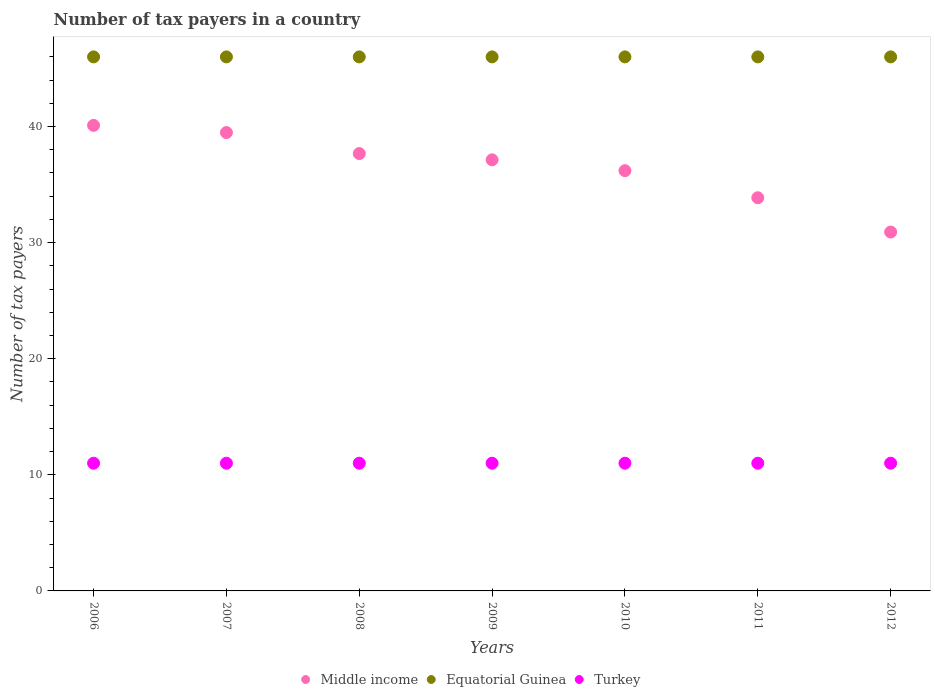How many different coloured dotlines are there?
Your answer should be compact. 3. What is the number of tax payers in in Turkey in 2011?
Your response must be concise. 11. Across all years, what is the maximum number of tax payers in in Middle income?
Offer a very short reply. 40.1. Across all years, what is the minimum number of tax payers in in Middle income?
Offer a terse response. 30.91. In which year was the number of tax payers in in Equatorial Guinea maximum?
Ensure brevity in your answer.  2006. What is the total number of tax payers in in Turkey in the graph?
Provide a short and direct response. 77. What is the difference between the number of tax payers in in Middle income in 2009 and that in 2010?
Your answer should be very brief. 0.93. What is the difference between the number of tax payers in in Middle income in 2006 and the number of tax payers in in Equatorial Guinea in 2012?
Keep it short and to the point. -5.9. What is the average number of tax payers in in Middle income per year?
Your answer should be very brief. 36.48. In the year 2006, what is the difference between the number of tax payers in in Equatorial Guinea and number of tax payers in in Turkey?
Provide a short and direct response. 35. What is the ratio of the number of tax payers in in Middle income in 2009 to that in 2010?
Offer a very short reply. 1.03. Is the number of tax payers in in Middle income in 2009 less than that in 2011?
Provide a succinct answer. No. Is the difference between the number of tax payers in in Equatorial Guinea in 2010 and 2012 greater than the difference between the number of tax payers in in Turkey in 2010 and 2012?
Your response must be concise. No. What is the difference between the highest and the second highest number of tax payers in in Middle income?
Provide a succinct answer. 0.62. What is the difference between the highest and the lowest number of tax payers in in Middle income?
Give a very brief answer. 9.19. In how many years, is the number of tax payers in in Turkey greater than the average number of tax payers in in Turkey taken over all years?
Make the answer very short. 0. Is it the case that in every year, the sum of the number of tax payers in in Equatorial Guinea and number of tax payers in in Turkey  is greater than the number of tax payers in in Middle income?
Make the answer very short. Yes. Is the number of tax payers in in Middle income strictly less than the number of tax payers in in Equatorial Guinea over the years?
Make the answer very short. Yes. How many years are there in the graph?
Offer a very short reply. 7. What is the difference between two consecutive major ticks on the Y-axis?
Make the answer very short. 10. Does the graph contain any zero values?
Provide a succinct answer. No. How many legend labels are there?
Offer a very short reply. 3. What is the title of the graph?
Your answer should be compact. Number of tax payers in a country. What is the label or title of the X-axis?
Make the answer very short. Years. What is the label or title of the Y-axis?
Ensure brevity in your answer.  Number of tax payers. What is the Number of tax payers in Middle income in 2006?
Make the answer very short. 40.1. What is the Number of tax payers of Middle income in 2007?
Keep it short and to the point. 39.48. What is the Number of tax payers in Equatorial Guinea in 2007?
Keep it short and to the point. 46. What is the Number of tax payers in Turkey in 2007?
Your answer should be compact. 11. What is the Number of tax payers of Middle income in 2008?
Your answer should be compact. 37.67. What is the Number of tax payers in Turkey in 2008?
Your answer should be compact. 11. What is the Number of tax payers in Middle income in 2009?
Provide a short and direct response. 37.13. What is the Number of tax payers in Middle income in 2010?
Provide a succinct answer. 36.2. What is the Number of tax payers of Equatorial Guinea in 2010?
Your answer should be very brief. 46. What is the Number of tax payers in Middle income in 2011?
Provide a succinct answer. 33.87. What is the Number of tax payers of Turkey in 2011?
Offer a terse response. 11. What is the Number of tax payers in Middle income in 2012?
Make the answer very short. 30.91. Across all years, what is the maximum Number of tax payers of Middle income?
Ensure brevity in your answer.  40.1. Across all years, what is the maximum Number of tax payers in Equatorial Guinea?
Make the answer very short. 46. Across all years, what is the minimum Number of tax payers of Middle income?
Offer a terse response. 30.91. Across all years, what is the minimum Number of tax payers of Equatorial Guinea?
Your answer should be very brief. 46. What is the total Number of tax payers of Middle income in the graph?
Your response must be concise. 255.37. What is the total Number of tax payers of Equatorial Guinea in the graph?
Offer a very short reply. 322. What is the total Number of tax payers in Turkey in the graph?
Your response must be concise. 77. What is the difference between the Number of tax payers in Middle income in 2006 and that in 2007?
Ensure brevity in your answer.  0.62. What is the difference between the Number of tax payers in Turkey in 2006 and that in 2007?
Ensure brevity in your answer.  0. What is the difference between the Number of tax payers of Middle income in 2006 and that in 2008?
Your answer should be compact. 2.43. What is the difference between the Number of tax payers in Equatorial Guinea in 2006 and that in 2008?
Your response must be concise. 0. What is the difference between the Number of tax payers of Turkey in 2006 and that in 2008?
Provide a succinct answer. 0. What is the difference between the Number of tax payers of Middle income in 2006 and that in 2009?
Make the answer very short. 2.97. What is the difference between the Number of tax payers of Equatorial Guinea in 2006 and that in 2009?
Offer a terse response. 0. What is the difference between the Number of tax payers in Turkey in 2006 and that in 2009?
Your answer should be compact. 0. What is the difference between the Number of tax payers in Middle income in 2006 and that in 2010?
Offer a very short reply. 3.9. What is the difference between the Number of tax payers of Equatorial Guinea in 2006 and that in 2010?
Offer a terse response. 0. What is the difference between the Number of tax payers in Turkey in 2006 and that in 2010?
Your answer should be compact. 0. What is the difference between the Number of tax payers of Middle income in 2006 and that in 2011?
Provide a succinct answer. 6.23. What is the difference between the Number of tax payers in Turkey in 2006 and that in 2011?
Make the answer very short. 0. What is the difference between the Number of tax payers of Middle income in 2006 and that in 2012?
Keep it short and to the point. 9.19. What is the difference between the Number of tax payers of Turkey in 2006 and that in 2012?
Give a very brief answer. 0. What is the difference between the Number of tax payers of Middle income in 2007 and that in 2008?
Your answer should be very brief. 1.81. What is the difference between the Number of tax payers of Middle income in 2007 and that in 2009?
Provide a succinct answer. 2.35. What is the difference between the Number of tax payers in Turkey in 2007 and that in 2009?
Your answer should be very brief. 0. What is the difference between the Number of tax payers of Middle income in 2007 and that in 2010?
Your answer should be compact. 3.28. What is the difference between the Number of tax payers of Equatorial Guinea in 2007 and that in 2010?
Provide a short and direct response. 0. What is the difference between the Number of tax payers of Turkey in 2007 and that in 2010?
Keep it short and to the point. 0. What is the difference between the Number of tax payers in Middle income in 2007 and that in 2011?
Provide a short and direct response. 5.62. What is the difference between the Number of tax payers in Equatorial Guinea in 2007 and that in 2011?
Your answer should be compact. 0. What is the difference between the Number of tax payers in Middle income in 2007 and that in 2012?
Make the answer very short. 8.57. What is the difference between the Number of tax payers in Turkey in 2007 and that in 2012?
Provide a succinct answer. 0. What is the difference between the Number of tax payers in Middle income in 2008 and that in 2009?
Your response must be concise. 0.54. What is the difference between the Number of tax payers of Equatorial Guinea in 2008 and that in 2009?
Offer a very short reply. 0. What is the difference between the Number of tax payers of Turkey in 2008 and that in 2009?
Offer a terse response. 0. What is the difference between the Number of tax payers of Middle income in 2008 and that in 2010?
Your answer should be compact. 1.47. What is the difference between the Number of tax payers in Equatorial Guinea in 2008 and that in 2010?
Keep it short and to the point. 0. What is the difference between the Number of tax payers of Turkey in 2008 and that in 2010?
Your response must be concise. 0. What is the difference between the Number of tax payers in Middle income in 2008 and that in 2011?
Your response must be concise. 3.81. What is the difference between the Number of tax payers in Middle income in 2008 and that in 2012?
Give a very brief answer. 6.76. What is the difference between the Number of tax payers in Middle income in 2009 and that in 2010?
Your answer should be compact. 0.93. What is the difference between the Number of tax payers in Turkey in 2009 and that in 2010?
Your answer should be compact. 0. What is the difference between the Number of tax payers of Middle income in 2009 and that in 2011?
Offer a very short reply. 3.27. What is the difference between the Number of tax payers in Middle income in 2009 and that in 2012?
Give a very brief answer. 6.22. What is the difference between the Number of tax payers of Turkey in 2009 and that in 2012?
Your answer should be compact. 0. What is the difference between the Number of tax payers of Middle income in 2010 and that in 2011?
Your answer should be very brief. 2.33. What is the difference between the Number of tax payers in Equatorial Guinea in 2010 and that in 2011?
Your answer should be very brief. 0. What is the difference between the Number of tax payers of Turkey in 2010 and that in 2011?
Provide a short and direct response. 0. What is the difference between the Number of tax payers of Middle income in 2010 and that in 2012?
Ensure brevity in your answer.  5.29. What is the difference between the Number of tax payers in Equatorial Guinea in 2010 and that in 2012?
Offer a terse response. 0. What is the difference between the Number of tax payers of Turkey in 2010 and that in 2012?
Make the answer very short. 0. What is the difference between the Number of tax payers of Middle income in 2011 and that in 2012?
Make the answer very short. 2.95. What is the difference between the Number of tax payers in Equatorial Guinea in 2011 and that in 2012?
Make the answer very short. 0. What is the difference between the Number of tax payers of Turkey in 2011 and that in 2012?
Keep it short and to the point. 0. What is the difference between the Number of tax payers in Middle income in 2006 and the Number of tax payers in Equatorial Guinea in 2007?
Offer a terse response. -5.9. What is the difference between the Number of tax payers in Middle income in 2006 and the Number of tax payers in Turkey in 2007?
Offer a terse response. 29.1. What is the difference between the Number of tax payers in Equatorial Guinea in 2006 and the Number of tax payers in Turkey in 2007?
Provide a short and direct response. 35. What is the difference between the Number of tax payers of Middle income in 2006 and the Number of tax payers of Equatorial Guinea in 2008?
Provide a short and direct response. -5.9. What is the difference between the Number of tax payers in Middle income in 2006 and the Number of tax payers in Turkey in 2008?
Your response must be concise. 29.1. What is the difference between the Number of tax payers in Middle income in 2006 and the Number of tax payers in Equatorial Guinea in 2009?
Provide a short and direct response. -5.9. What is the difference between the Number of tax payers of Middle income in 2006 and the Number of tax payers of Turkey in 2009?
Provide a short and direct response. 29.1. What is the difference between the Number of tax payers of Middle income in 2006 and the Number of tax payers of Equatorial Guinea in 2010?
Provide a short and direct response. -5.9. What is the difference between the Number of tax payers in Middle income in 2006 and the Number of tax payers in Turkey in 2010?
Your answer should be compact. 29.1. What is the difference between the Number of tax payers of Equatorial Guinea in 2006 and the Number of tax payers of Turkey in 2010?
Your answer should be compact. 35. What is the difference between the Number of tax payers in Middle income in 2006 and the Number of tax payers in Equatorial Guinea in 2011?
Provide a short and direct response. -5.9. What is the difference between the Number of tax payers of Middle income in 2006 and the Number of tax payers of Turkey in 2011?
Offer a very short reply. 29.1. What is the difference between the Number of tax payers of Middle income in 2006 and the Number of tax payers of Equatorial Guinea in 2012?
Keep it short and to the point. -5.9. What is the difference between the Number of tax payers in Middle income in 2006 and the Number of tax payers in Turkey in 2012?
Offer a very short reply. 29.1. What is the difference between the Number of tax payers in Middle income in 2007 and the Number of tax payers in Equatorial Guinea in 2008?
Give a very brief answer. -6.52. What is the difference between the Number of tax payers in Middle income in 2007 and the Number of tax payers in Turkey in 2008?
Your answer should be compact. 28.48. What is the difference between the Number of tax payers of Equatorial Guinea in 2007 and the Number of tax payers of Turkey in 2008?
Provide a succinct answer. 35. What is the difference between the Number of tax payers in Middle income in 2007 and the Number of tax payers in Equatorial Guinea in 2009?
Ensure brevity in your answer.  -6.52. What is the difference between the Number of tax payers in Middle income in 2007 and the Number of tax payers in Turkey in 2009?
Keep it short and to the point. 28.48. What is the difference between the Number of tax payers in Middle income in 2007 and the Number of tax payers in Equatorial Guinea in 2010?
Your answer should be compact. -6.52. What is the difference between the Number of tax payers in Middle income in 2007 and the Number of tax payers in Turkey in 2010?
Offer a very short reply. 28.48. What is the difference between the Number of tax payers of Middle income in 2007 and the Number of tax payers of Equatorial Guinea in 2011?
Offer a very short reply. -6.52. What is the difference between the Number of tax payers of Middle income in 2007 and the Number of tax payers of Turkey in 2011?
Your response must be concise. 28.48. What is the difference between the Number of tax payers of Equatorial Guinea in 2007 and the Number of tax payers of Turkey in 2011?
Your response must be concise. 35. What is the difference between the Number of tax payers in Middle income in 2007 and the Number of tax payers in Equatorial Guinea in 2012?
Your answer should be very brief. -6.52. What is the difference between the Number of tax payers of Middle income in 2007 and the Number of tax payers of Turkey in 2012?
Provide a short and direct response. 28.48. What is the difference between the Number of tax payers in Equatorial Guinea in 2007 and the Number of tax payers in Turkey in 2012?
Provide a short and direct response. 35. What is the difference between the Number of tax payers in Middle income in 2008 and the Number of tax payers in Equatorial Guinea in 2009?
Your answer should be compact. -8.33. What is the difference between the Number of tax payers in Middle income in 2008 and the Number of tax payers in Turkey in 2009?
Ensure brevity in your answer.  26.67. What is the difference between the Number of tax payers in Middle income in 2008 and the Number of tax payers in Equatorial Guinea in 2010?
Ensure brevity in your answer.  -8.33. What is the difference between the Number of tax payers of Middle income in 2008 and the Number of tax payers of Turkey in 2010?
Provide a succinct answer. 26.67. What is the difference between the Number of tax payers of Equatorial Guinea in 2008 and the Number of tax payers of Turkey in 2010?
Offer a terse response. 35. What is the difference between the Number of tax payers in Middle income in 2008 and the Number of tax payers in Equatorial Guinea in 2011?
Your answer should be very brief. -8.33. What is the difference between the Number of tax payers of Middle income in 2008 and the Number of tax payers of Turkey in 2011?
Keep it short and to the point. 26.67. What is the difference between the Number of tax payers of Equatorial Guinea in 2008 and the Number of tax payers of Turkey in 2011?
Your answer should be compact. 35. What is the difference between the Number of tax payers in Middle income in 2008 and the Number of tax payers in Equatorial Guinea in 2012?
Ensure brevity in your answer.  -8.33. What is the difference between the Number of tax payers in Middle income in 2008 and the Number of tax payers in Turkey in 2012?
Ensure brevity in your answer.  26.67. What is the difference between the Number of tax payers of Middle income in 2009 and the Number of tax payers of Equatorial Guinea in 2010?
Provide a short and direct response. -8.87. What is the difference between the Number of tax payers of Middle income in 2009 and the Number of tax payers of Turkey in 2010?
Offer a very short reply. 26.13. What is the difference between the Number of tax payers of Middle income in 2009 and the Number of tax payers of Equatorial Guinea in 2011?
Your answer should be very brief. -8.87. What is the difference between the Number of tax payers of Middle income in 2009 and the Number of tax payers of Turkey in 2011?
Your response must be concise. 26.13. What is the difference between the Number of tax payers of Equatorial Guinea in 2009 and the Number of tax payers of Turkey in 2011?
Ensure brevity in your answer.  35. What is the difference between the Number of tax payers of Middle income in 2009 and the Number of tax payers of Equatorial Guinea in 2012?
Your answer should be very brief. -8.87. What is the difference between the Number of tax payers of Middle income in 2009 and the Number of tax payers of Turkey in 2012?
Provide a succinct answer. 26.13. What is the difference between the Number of tax payers in Equatorial Guinea in 2009 and the Number of tax payers in Turkey in 2012?
Your answer should be very brief. 35. What is the difference between the Number of tax payers in Middle income in 2010 and the Number of tax payers in Equatorial Guinea in 2011?
Give a very brief answer. -9.8. What is the difference between the Number of tax payers in Middle income in 2010 and the Number of tax payers in Turkey in 2011?
Your answer should be very brief. 25.2. What is the difference between the Number of tax payers in Equatorial Guinea in 2010 and the Number of tax payers in Turkey in 2011?
Give a very brief answer. 35. What is the difference between the Number of tax payers in Middle income in 2010 and the Number of tax payers in Equatorial Guinea in 2012?
Provide a succinct answer. -9.8. What is the difference between the Number of tax payers in Middle income in 2010 and the Number of tax payers in Turkey in 2012?
Give a very brief answer. 25.2. What is the difference between the Number of tax payers in Equatorial Guinea in 2010 and the Number of tax payers in Turkey in 2012?
Give a very brief answer. 35. What is the difference between the Number of tax payers in Middle income in 2011 and the Number of tax payers in Equatorial Guinea in 2012?
Keep it short and to the point. -12.13. What is the difference between the Number of tax payers in Middle income in 2011 and the Number of tax payers in Turkey in 2012?
Provide a succinct answer. 22.87. What is the average Number of tax payers in Middle income per year?
Give a very brief answer. 36.48. What is the average Number of tax payers in Equatorial Guinea per year?
Provide a succinct answer. 46. In the year 2006, what is the difference between the Number of tax payers in Middle income and Number of tax payers in Equatorial Guinea?
Ensure brevity in your answer.  -5.9. In the year 2006, what is the difference between the Number of tax payers in Middle income and Number of tax payers in Turkey?
Make the answer very short. 29.1. In the year 2007, what is the difference between the Number of tax payers of Middle income and Number of tax payers of Equatorial Guinea?
Ensure brevity in your answer.  -6.52. In the year 2007, what is the difference between the Number of tax payers in Middle income and Number of tax payers in Turkey?
Offer a very short reply. 28.48. In the year 2008, what is the difference between the Number of tax payers of Middle income and Number of tax payers of Equatorial Guinea?
Provide a succinct answer. -8.33. In the year 2008, what is the difference between the Number of tax payers in Middle income and Number of tax payers in Turkey?
Offer a very short reply. 26.67. In the year 2009, what is the difference between the Number of tax payers of Middle income and Number of tax payers of Equatorial Guinea?
Offer a terse response. -8.87. In the year 2009, what is the difference between the Number of tax payers in Middle income and Number of tax payers in Turkey?
Give a very brief answer. 26.13. In the year 2009, what is the difference between the Number of tax payers in Equatorial Guinea and Number of tax payers in Turkey?
Keep it short and to the point. 35. In the year 2010, what is the difference between the Number of tax payers of Middle income and Number of tax payers of Turkey?
Offer a terse response. 25.2. In the year 2010, what is the difference between the Number of tax payers in Equatorial Guinea and Number of tax payers in Turkey?
Provide a short and direct response. 35. In the year 2011, what is the difference between the Number of tax payers of Middle income and Number of tax payers of Equatorial Guinea?
Your answer should be very brief. -12.13. In the year 2011, what is the difference between the Number of tax payers in Middle income and Number of tax payers in Turkey?
Offer a very short reply. 22.87. In the year 2012, what is the difference between the Number of tax payers in Middle income and Number of tax payers in Equatorial Guinea?
Make the answer very short. -15.09. In the year 2012, what is the difference between the Number of tax payers of Middle income and Number of tax payers of Turkey?
Offer a terse response. 19.91. What is the ratio of the Number of tax payers in Middle income in 2006 to that in 2007?
Give a very brief answer. 1.02. What is the ratio of the Number of tax payers in Equatorial Guinea in 2006 to that in 2007?
Give a very brief answer. 1. What is the ratio of the Number of tax payers in Turkey in 2006 to that in 2007?
Make the answer very short. 1. What is the ratio of the Number of tax payers in Middle income in 2006 to that in 2008?
Keep it short and to the point. 1.06. What is the ratio of the Number of tax payers in Equatorial Guinea in 2006 to that in 2008?
Offer a terse response. 1. What is the ratio of the Number of tax payers in Middle income in 2006 to that in 2009?
Your answer should be very brief. 1.08. What is the ratio of the Number of tax payers in Middle income in 2006 to that in 2010?
Offer a very short reply. 1.11. What is the ratio of the Number of tax payers of Equatorial Guinea in 2006 to that in 2010?
Provide a short and direct response. 1. What is the ratio of the Number of tax payers of Middle income in 2006 to that in 2011?
Give a very brief answer. 1.18. What is the ratio of the Number of tax payers of Equatorial Guinea in 2006 to that in 2011?
Ensure brevity in your answer.  1. What is the ratio of the Number of tax payers of Turkey in 2006 to that in 2011?
Keep it short and to the point. 1. What is the ratio of the Number of tax payers of Middle income in 2006 to that in 2012?
Your answer should be compact. 1.3. What is the ratio of the Number of tax payers of Equatorial Guinea in 2006 to that in 2012?
Provide a succinct answer. 1. What is the ratio of the Number of tax payers in Turkey in 2006 to that in 2012?
Offer a terse response. 1. What is the ratio of the Number of tax payers of Middle income in 2007 to that in 2008?
Provide a succinct answer. 1.05. What is the ratio of the Number of tax payers of Middle income in 2007 to that in 2009?
Your answer should be compact. 1.06. What is the ratio of the Number of tax payers of Equatorial Guinea in 2007 to that in 2009?
Offer a terse response. 1. What is the ratio of the Number of tax payers in Turkey in 2007 to that in 2009?
Give a very brief answer. 1. What is the ratio of the Number of tax payers in Middle income in 2007 to that in 2010?
Give a very brief answer. 1.09. What is the ratio of the Number of tax payers in Equatorial Guinea in 2007 to that in 2010?
Give a very brief answer. 1. What is the ratio of the Number of tax payers of Middle income in 2007 to that in 2011?
Ensure brevity in your answer.  1.17. What is the ratio of the Number of tax payers of Equatorial Guinea in 2007 to that in 2011?
Provide a succinct answer. 1. What is the ratio of the Number of tax payers of Turkey in 2007 to that in 2011?
Your response must be concise. 1. What is the ratio of the Number of tax payers of Middle income in 2007 to that in 2012?
Your response must be concise. 1.28. What is the ratio of the Number of tax payers in Turkey in 2007 to that in 2012?
Make the answer very short. 1. What is the ratio of the Number of tax payers of Middle income in 2008 to that in 2009?
Keep it short and to the point. 1.01. What is the ratio of the Number of tax payers of Turkey in 2008 to that in 2009?
Make the answer very short. 1. What is the ratio of the Number of tax payers of Middle income in 2008 to that in 2010?
Your response must be concise. 1.04. What is the ratio of the Number of tax payers of Equatorial Guinea in 2008 to that in 2010?
Make the answer very short. 1. What is the ratio of the Number of tax payers in Turkey in 2008 to that in 2010?
Ensure brevity in your answer.  1. What is the ratio of the Number of tax payers of Middle income in 2008 to that in 2011?
Ensure brevity in your answer.  1.11. What is the ratio of the Number of tax payers of Equatorial Guinea in 2008 to that in 2011?
Ensure brevity in your answer.  1. What is the ratio of the Number of tax payers of Middle income in 2008 to that in 2012?
Make the answer very short. 1.22. What is the ratio of the Number of tax payers of Equatorial Guinea in 2008 to that in 2012?
Give a very brief answer. 1. What is the ratio of the Number of tax payers of Middle income in 2009 to that in 2010?
Make the answer very short. 1.03. What is the ratio of the Number of tax payers in Equatorial Guinea in 2009 to that in 2010?
Your response must be concise. 1. What is the ratio of the Number of tax payers in Middle income in 2009 to that in 2011?
Your response must be concise. 1.1. What is the ratio of the Number of tax payers of Middle income in 2009 to that in 2012?
Ensure brevity in your answer.  1.2. What is the ratio of the Number of tax payers in Turkey in 2009 to that in 2012?
Your answer should be very brief. 1. What is the ratio of the Number of tax payers of Middle income in 2010 to that in 2011?
Your answer should be compact. 1.07. What is the ratio of the Number of tax payers of Equatorial Guinea in 2010 to that in 2011?
Your response must be concise. 1. What is the ratio of the Number of tax payers of Middle income in 2010 to that in 2012?
Provide a succinct answer. 1.17. What is the ratio of the Number of tax payers of Turkey in 2010 to that in 2012?
Your response must be concise. 1. What is the ratio of the Number of tax payers of Middle income in 2011 to that in 2012?
Make the answer very short. 1.1. What is the ratio of the Number of tax payers of Equatorial Guinea in 2011 to that in 2012?
Keep it short and to the point. 1. What is the difference between the highest and the second highest Number of tax payers in Middle income?
Your answer should be compact. 0.62. What is the difference between the highest and the lowest Number of tax payers of Middle income?
Offer a very short reply. 9.19. What is the difference between the highest and the lowest Number of tax payers of Equatorial Guinea?
Offer a very short reply. 0. What is the difference between the highest and the lowest Number of tax payers of Turkey?
Ensure brevity in your answer.  0. 